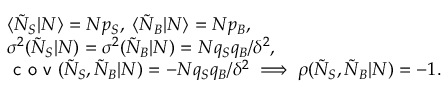Convert formula to latex. <formula><loc_0><loc_0><loc_500><loc_500>\begin{array} { r l } & { \langle \tilde { N } _ { S } | N \rangle = N p _ { S } , \, \langle \tilde { N } _ { B } | N \rangle = N p _ { B } , } \\ & { \sigma ^ { 2 } ( \tilde { N } _ { S } | N ) = \sigma ^ { 2 } ( \tilde { N } _ { B } | N ) = N q _ { S } q _ { B } / \delta ^ { 2 } , } \\ & { c o v ( \tilde { N } _ { S } , \tilde { N } _ { B } | N ) = - N q _ { S } q _ { B } / \delta ^ { 2 } \, \Longrightarrow \, \rho ( \tilde { N } _ { S } , \tilde { N } _ { B } | N ) = - 1 . } \end{array}</formula> 